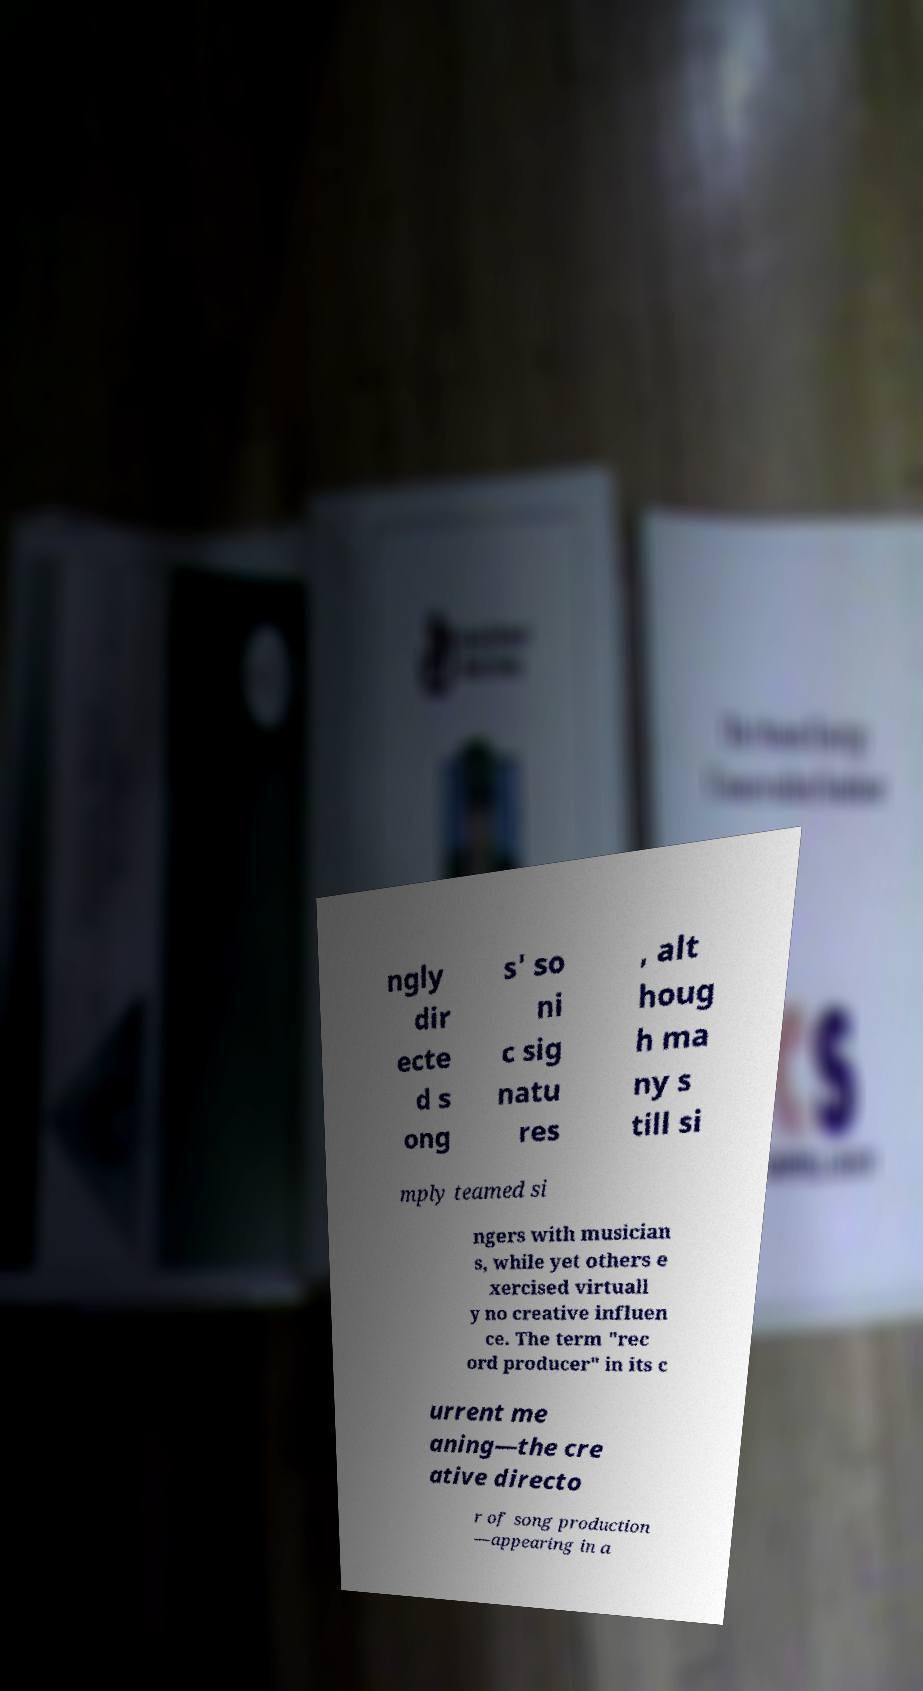Could you assist in decoding the text presented in this image and type it out clearly? ngly dir ecte d s ong s' so ni c sig natu res , alt houg h ma ny s till si mply teamed si ngers with musician s, while yet others e xercised virtuall y no creative influen ce. The term "rec ord producer" in its c urrent me aning—the cre ative directo r of song production —appearing in a 